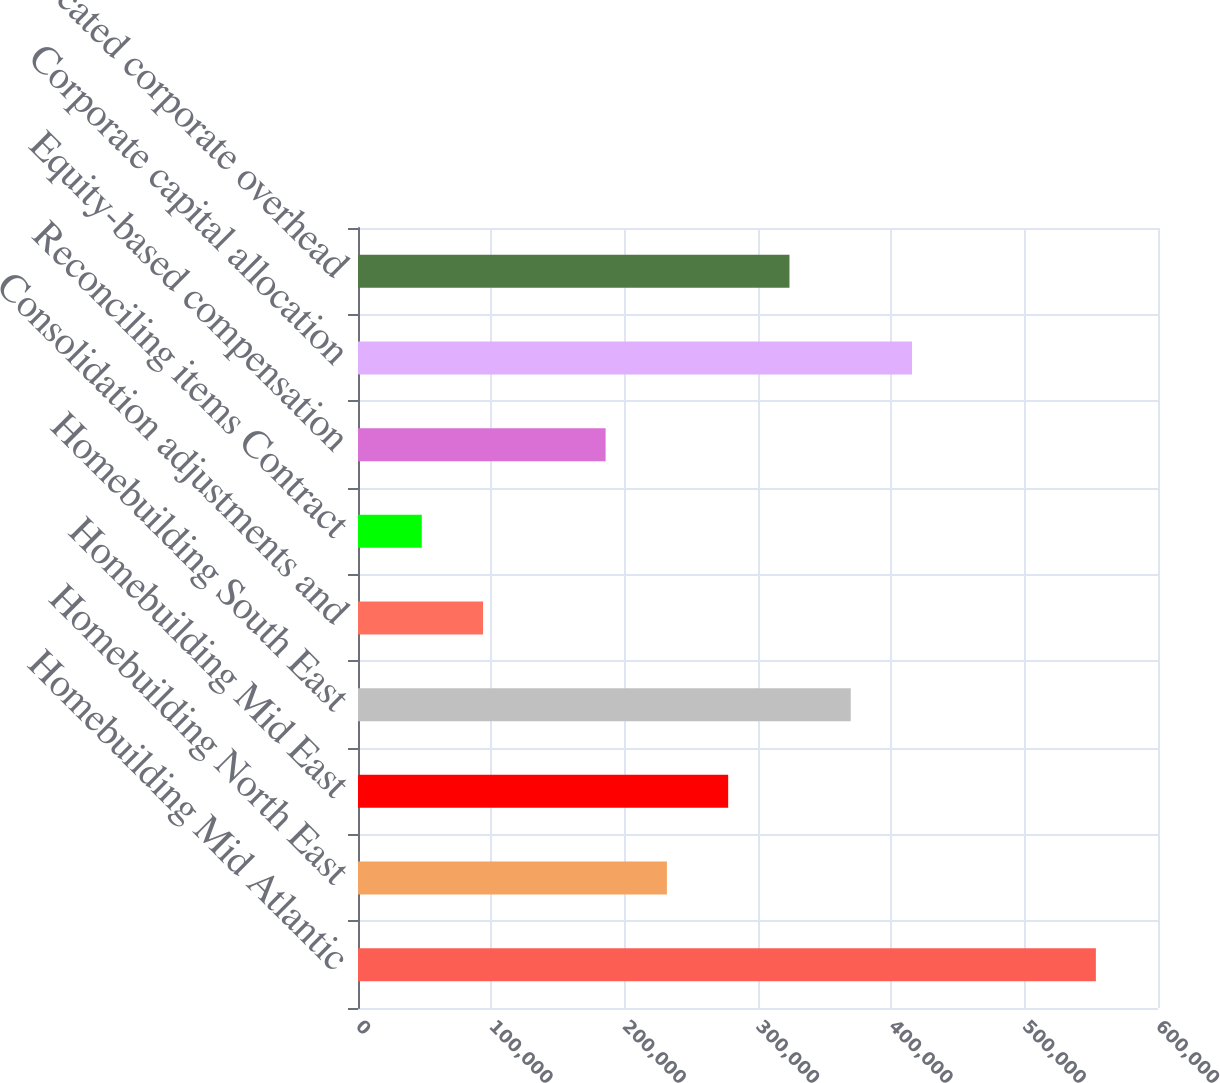Convert chart. <chart><loc_0><loc_0><loc_500><loc_500><bar_chart><fcel>Homebuilding Mid Atlantic<fcel>Homebuilding North East<fcel>Homebuilding Mid East<fcel>Homebuilding South East<fcel>Consolidation adjustments and<fcel>Reconciling items Contract<fcel>Equity-based compensation<fcel>Corporate capital allocation<fcel>Unallocated corporate overhead<nl><fcel>553405<fcel>231671<fcel>277633<fcel>369557<fcel>93785<fcel>47823<fcel>185709<fcel>415519<fcel>323595<nl></chart> 